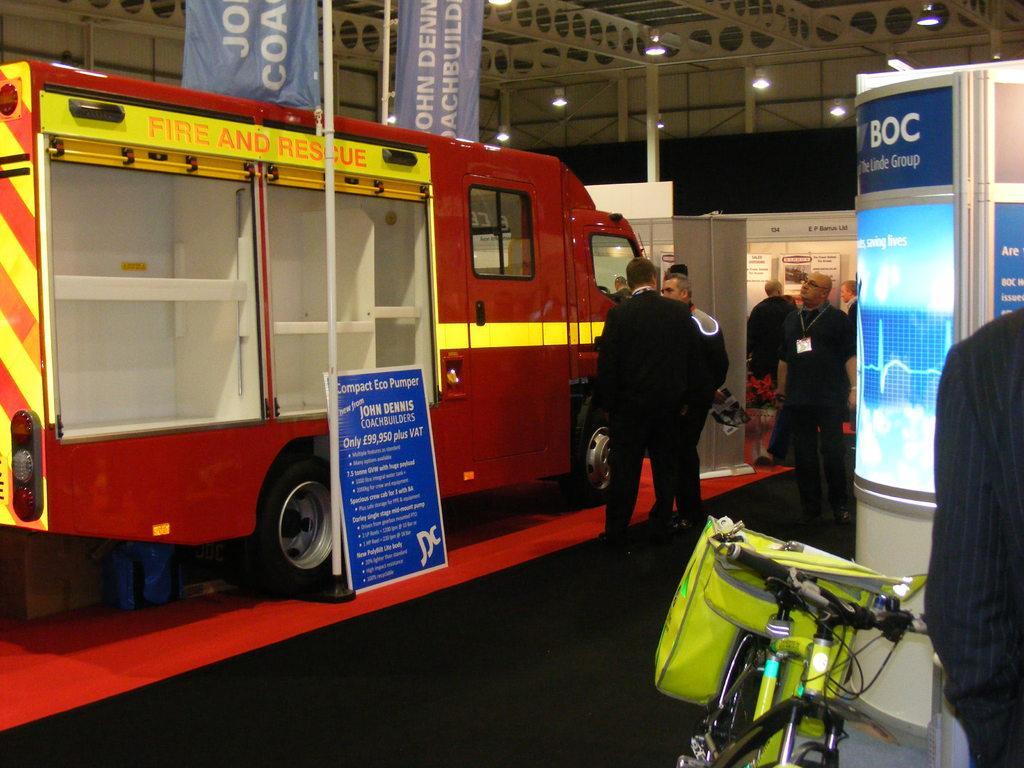How would you summarize this image in a sentence or two? In this picture I can see a fire engine and a board on the left side, in the middle there are group of people. On the right side there are boards with the lights, at the bottom I can see a cycle. At the top there are ceiling lights and the banners. 